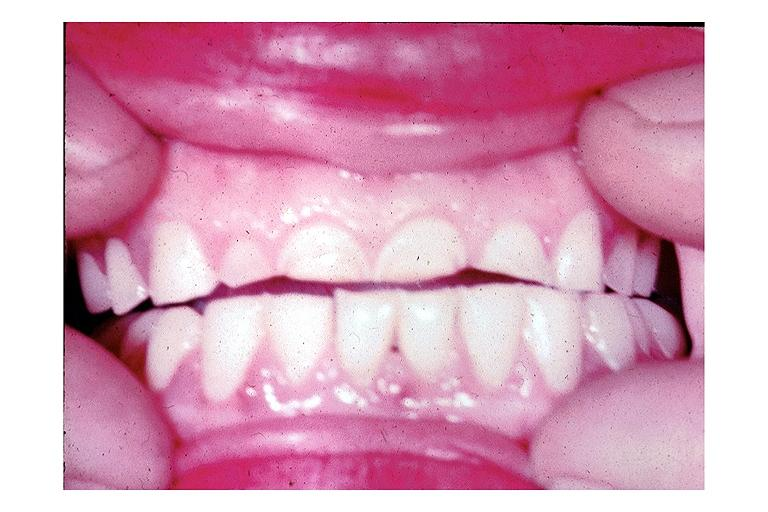s oral present?
Answer the question using a single word or phrase. Yes 